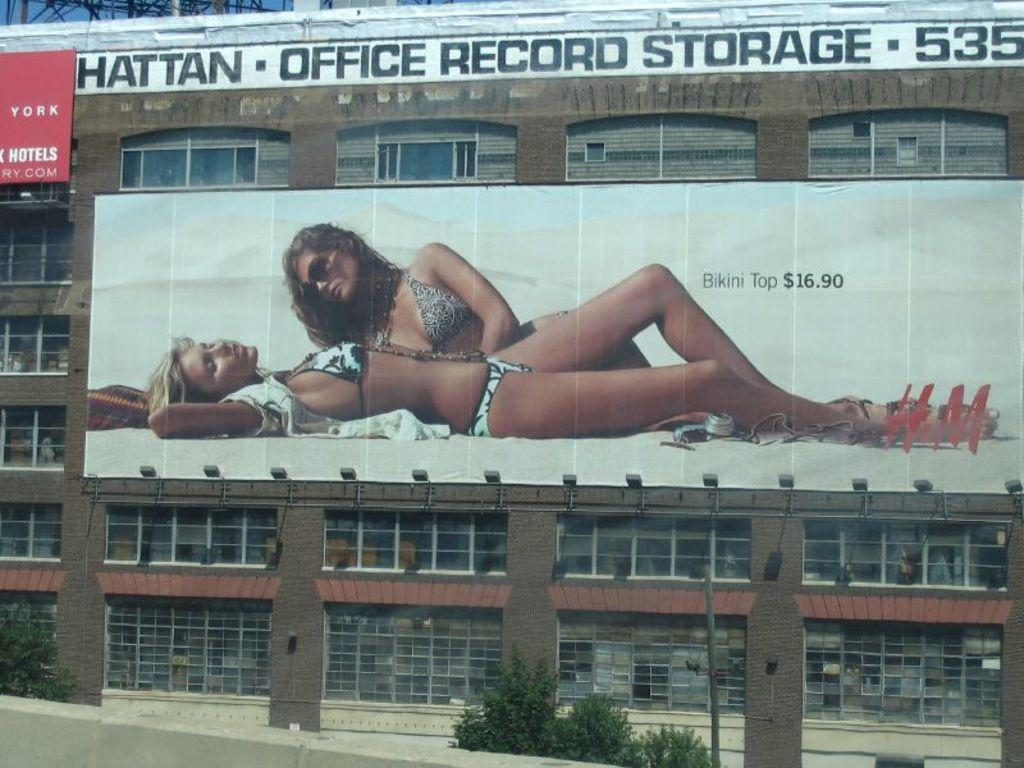<image>
Write a terse but informative summary of the picture. a billboard for H&M showing bikini top priced at $16.90 